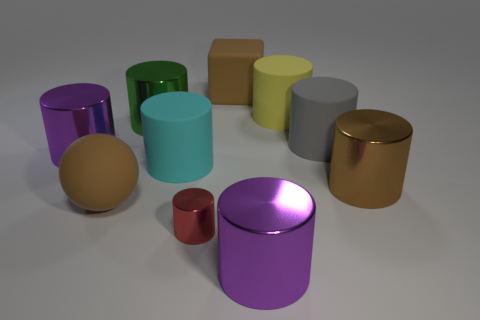What is the material of the large purple object that is left of the large metallic object behind the gray cylinder on the right side of the large yellow matte object?
Ensure brevity in your answer.  Metal. Are there the same number of large rubber cylinders that are to the left of the small cylinder and small red rubber balls?
Make the answer very short. No. Does the large purple object on the right side of the brown block have the same material as the big brown thing on the right side of the gray object?
Give a very brief answer. Yes. How many objects are either gray matte things or large objects that are to the left of the large gray cylinder?
Provide a succinct answer. 8. Are there any big yellow rubber things that have the same shape as the tiny red thing?
Make the answer very short. Yes. There is a purple cylinder in front of the brown rubber object in front of the shiny cylinder on the right side of the gray cylinder; what is its size?
Make the answer very short. Large. Are there the same number of brown cylinders right of the large brown block and big gray cylinders that are left of the small object?
Your response must be concise. No. What is the size of the gray thing that is made of the same material as the large cyan cylinder?
Make the answer very short. Large. What color is the small shiny cylinder?
Make the answer very short. Red. How many matte spheres are the same color as the big cube?
Provide a succinct answer. 1. 